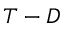Convert formula to latex. <formula><loc_0><loc_0><loc_500><loc_500>T - D</formula> 